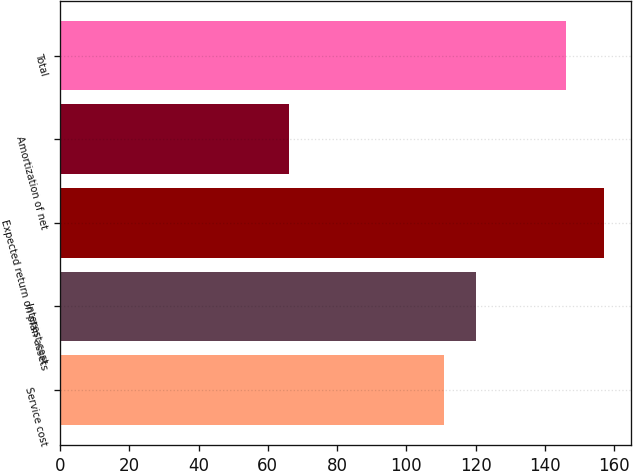Convert chart to OTSL. <chart><loc_0><loc_0><loc_500><loc_500><bar_chart><fcel>Service cost<fcel>Interest cost<fcel>Expected return on plan assets<fcel>Amortization of net<fcel>Total<nl><fcel>111<fcel>120.1<fcel>157<fcel>66<fcel>146<nl></chart> 